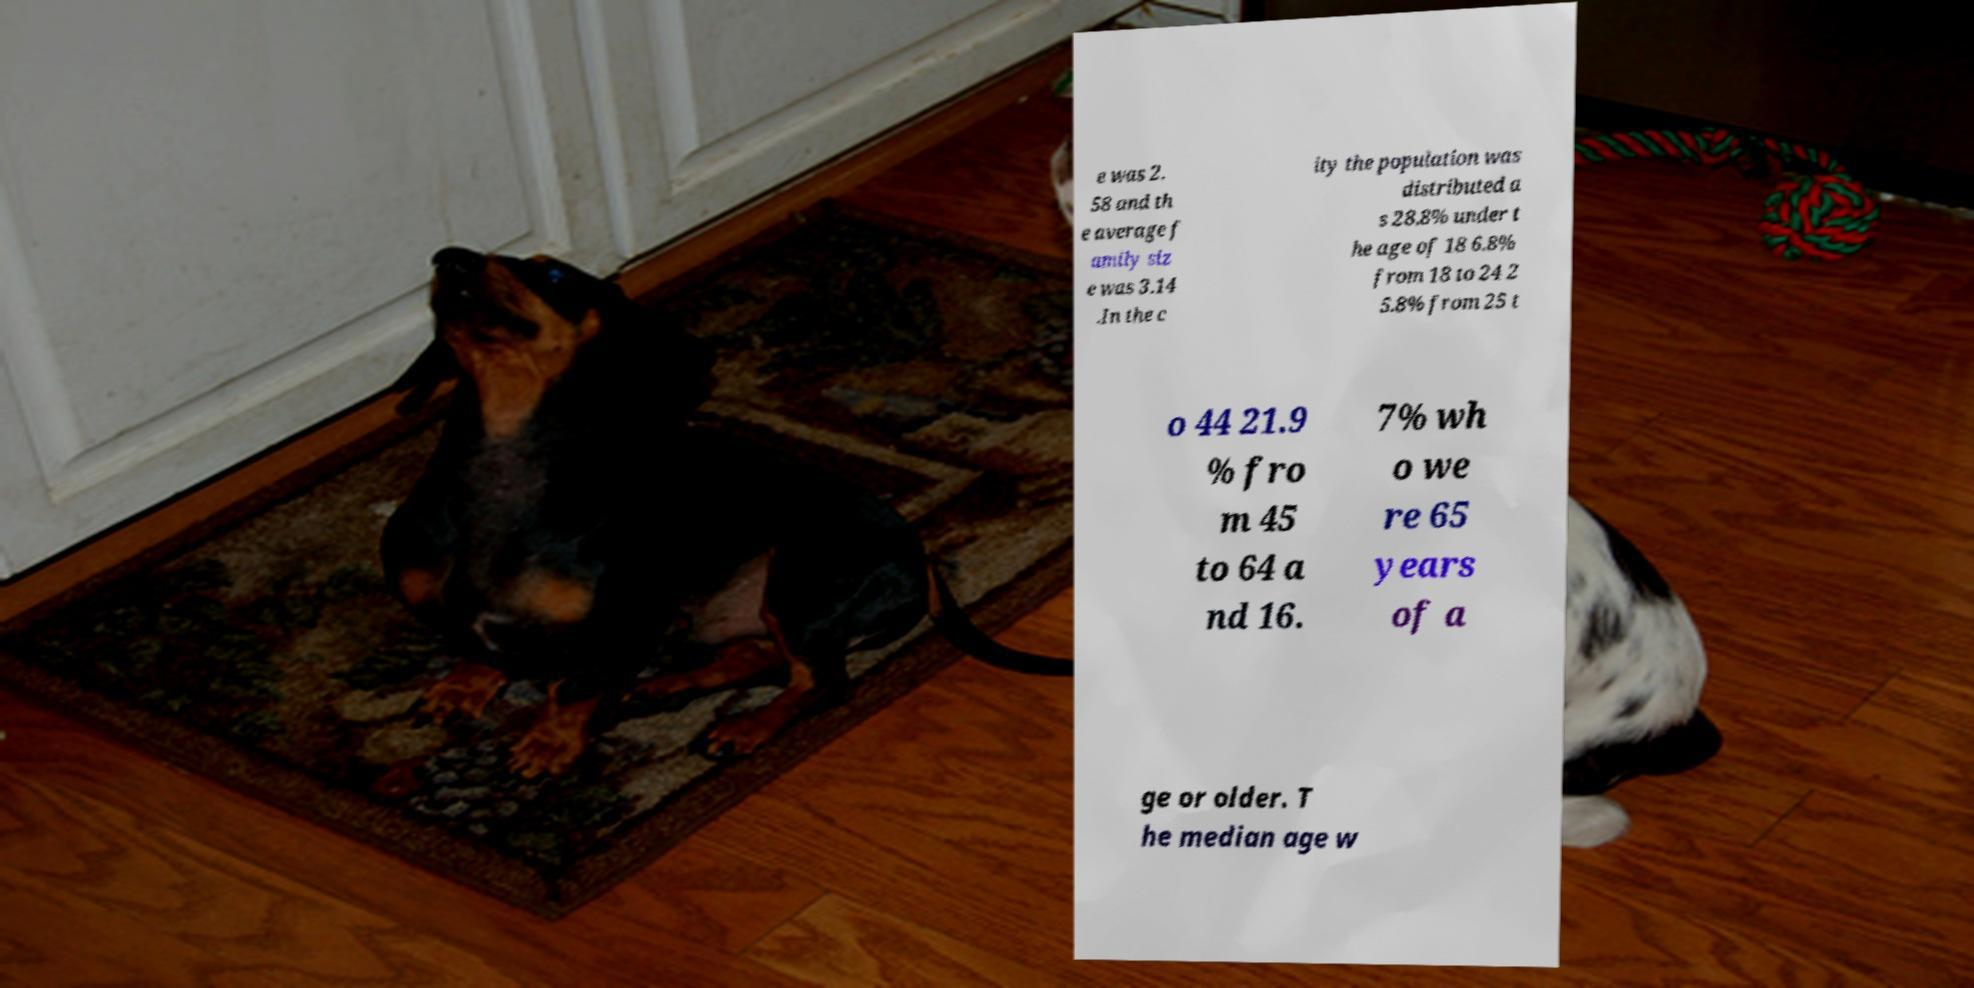There's text embedded in this image that I need extracted. Can you transcribe it verbatim? e was 2. 58 and th e average f amily siz e was 3.14 .In the c ity the population was distributed a s 28.8% under t he age of 18 6.8% from 18 to 24 2 5.8% from 25 t o 44 21.9 % fro m 45 to 64 a nd 16. 7% wh o we re 65 years of a ge or older. T he median age w 